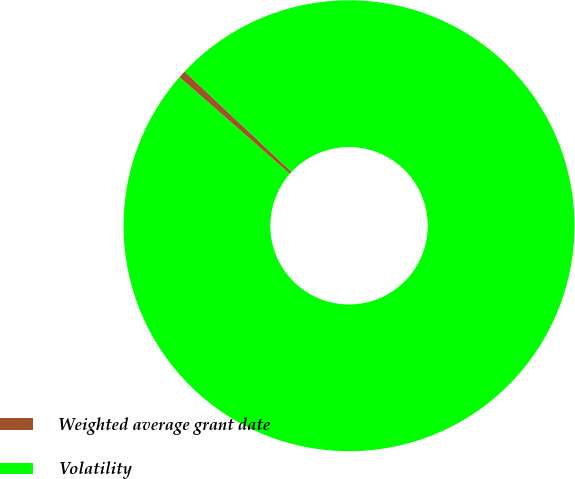Convert chart to OTSL. <chart><loc_0><loc_0><loc_500><loc_500><pie_chart><fcel>Weighted average grant date<fcel>Volatility<nl><fcel>0.55%<fcel>99.45%<nl></chart> 